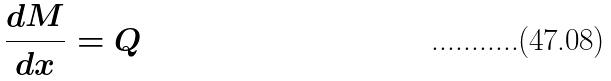<formula> <loc_0><loc_0><loc_500><loc_500>\frac { d M } { d x } = Q</formula> 